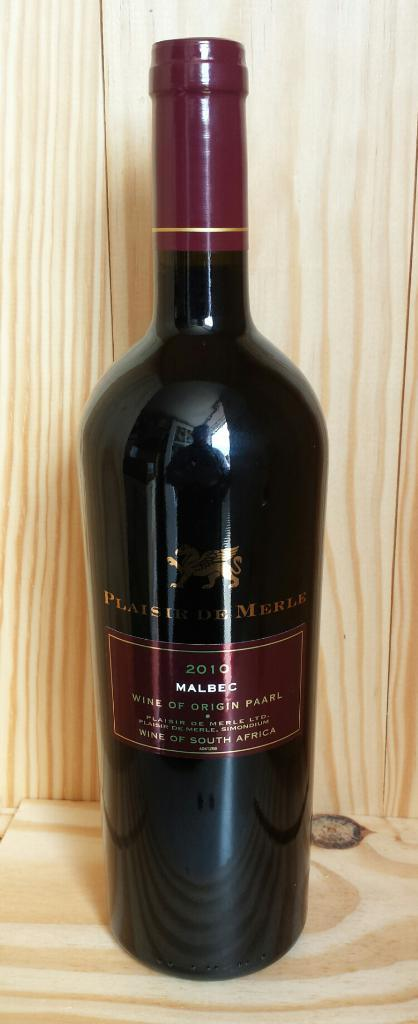Provide a one-sentence caption for the provided image. A 2010 bottle of Wine sitting on a wooden shelf or palette. 